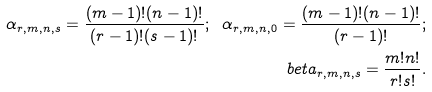<formula> <loc_0><loc_0><loc_500><loc_500>\alpha _ { r , m , n , s } = \frac { ( m - 1 ) ! ( n - 1 ) ! } { ( r - 1 ) ! ( s - 1 ) ! } ; \ \alpha _ { r , m , n , 0 } = \frac { ( m - 1 ) ! ( n - 1 ) ! } { ( r - 1 ) ! } ; \\ b e t a _ { r , m , n , s } = \frac { m ! n ! } { r ! s ! } .</formula> 